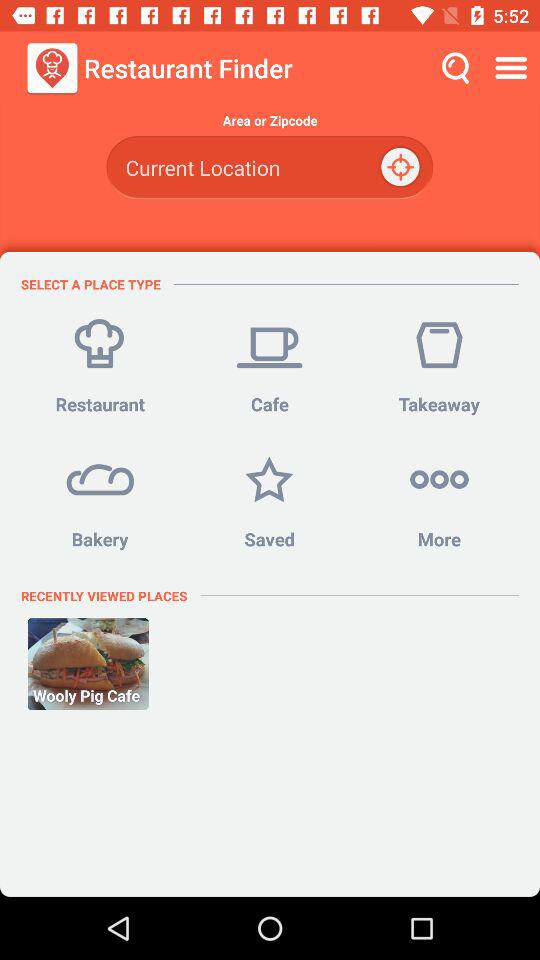What places have been seen recently? The recently seen place is the Wooly Pig Cafe. 